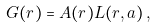Convert formula to latex. <formula><loc_0><loc_0><loc_500><loc_500>G ( r ) = A ( r ) L ( r , a ) \, ,</formula> 